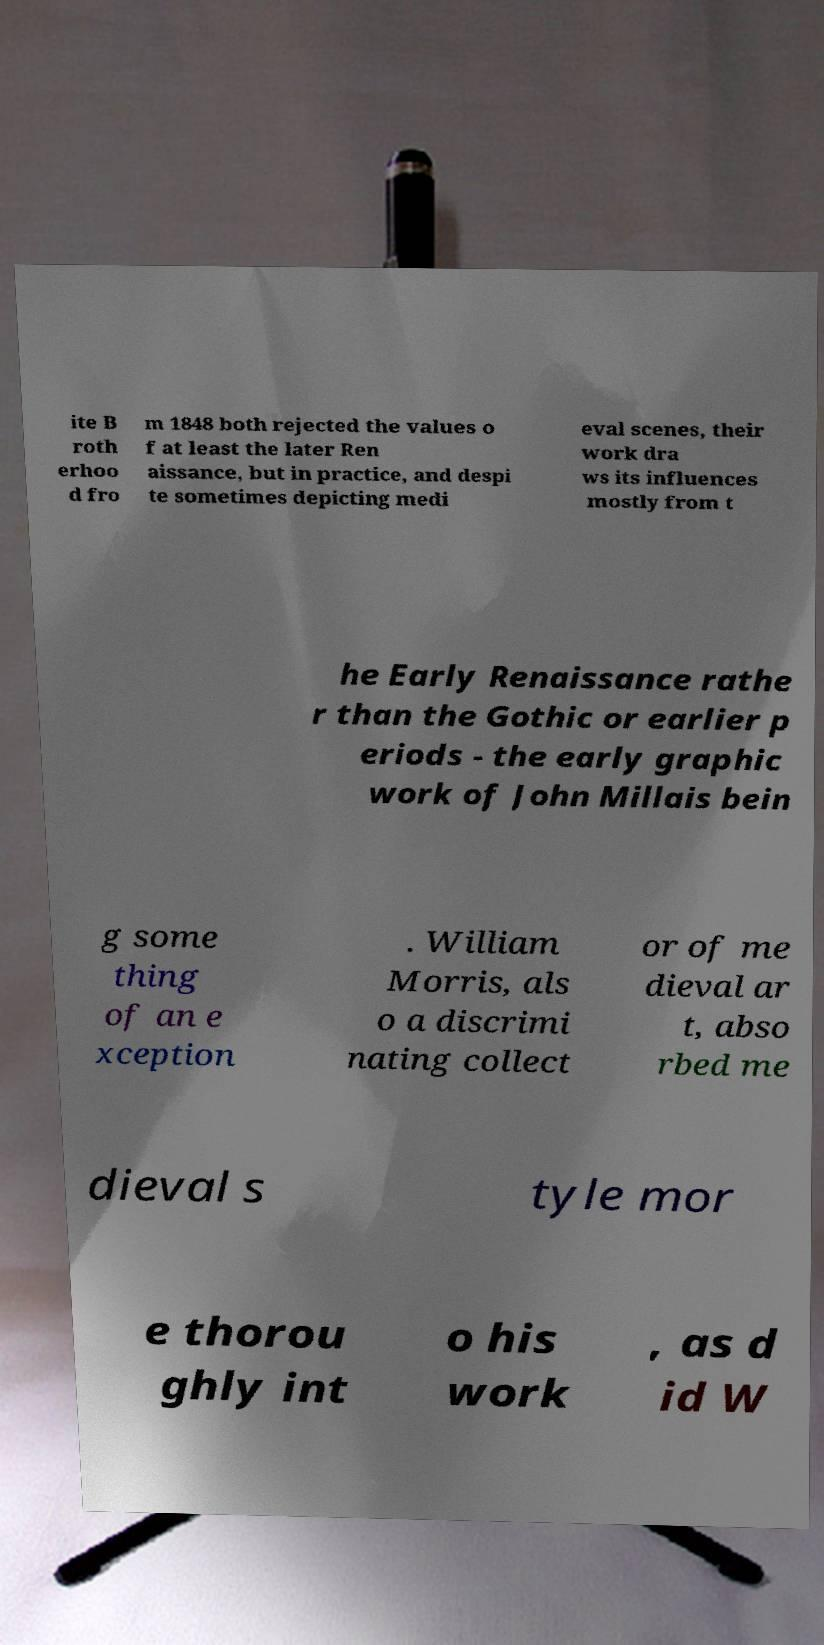I need the written content from this picture converted into text. Can you do that? ite B roth erhoo d fro m 1848 both rejected the values o f at least the later Ren aissance, but in practice, and despi te sometimes depicting medi eval scenes, their work dra ws its influences mostly from t he Early Renaissance rathe r than the Gothic or earlier p eriods - the early graphic work of John Millais bein g some thing of an e xception . William Morris, als o a discrimi nating collect or of me dieval ar t, abso rbed me dieval s tyle mor e thorou ghly int o his work , as d id W 